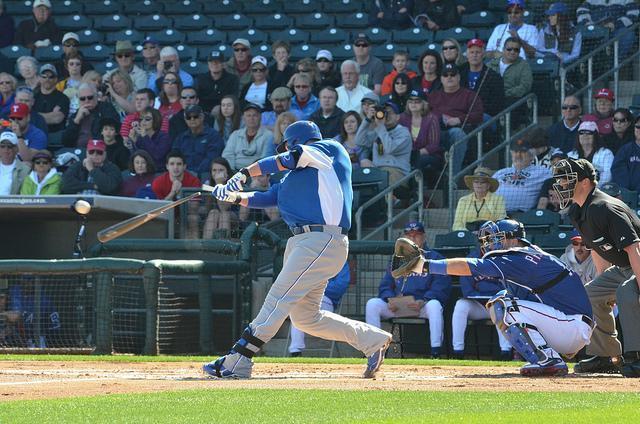How many people are visible?
Give a very brief answer. 10. How many toilet bowl brushes are in this picture?
Give a very brief answer. 0. 